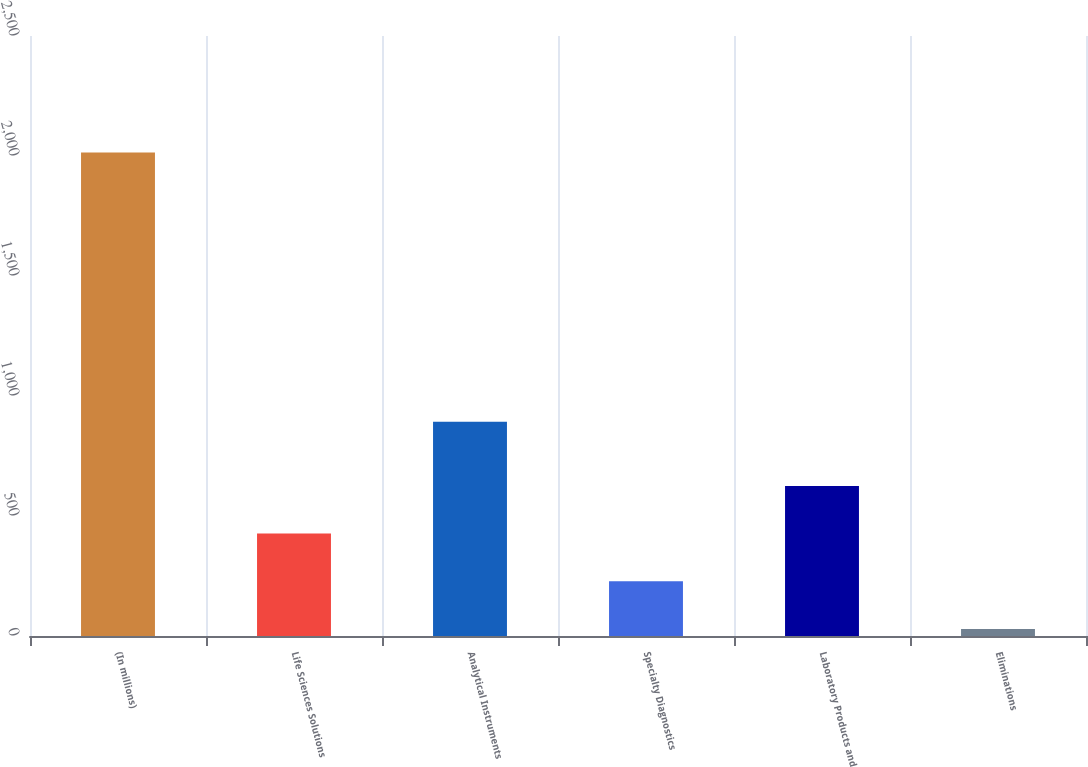<chart> <loc_0><loc_0><loc_500><loc_500><bar_chart><fcel>(In millions)<fcel>Life Sciences Solutions<fcel>Analytical Instruments<fcel>Specialty Diagnostics<fcel>Laboratory Products and<fcel>Eliminations<nl><fcel>2015<fcel>426.6<fcel>893.2<fcel>228.05<fcel>625.15<fcel>29.5<nl></chart> 